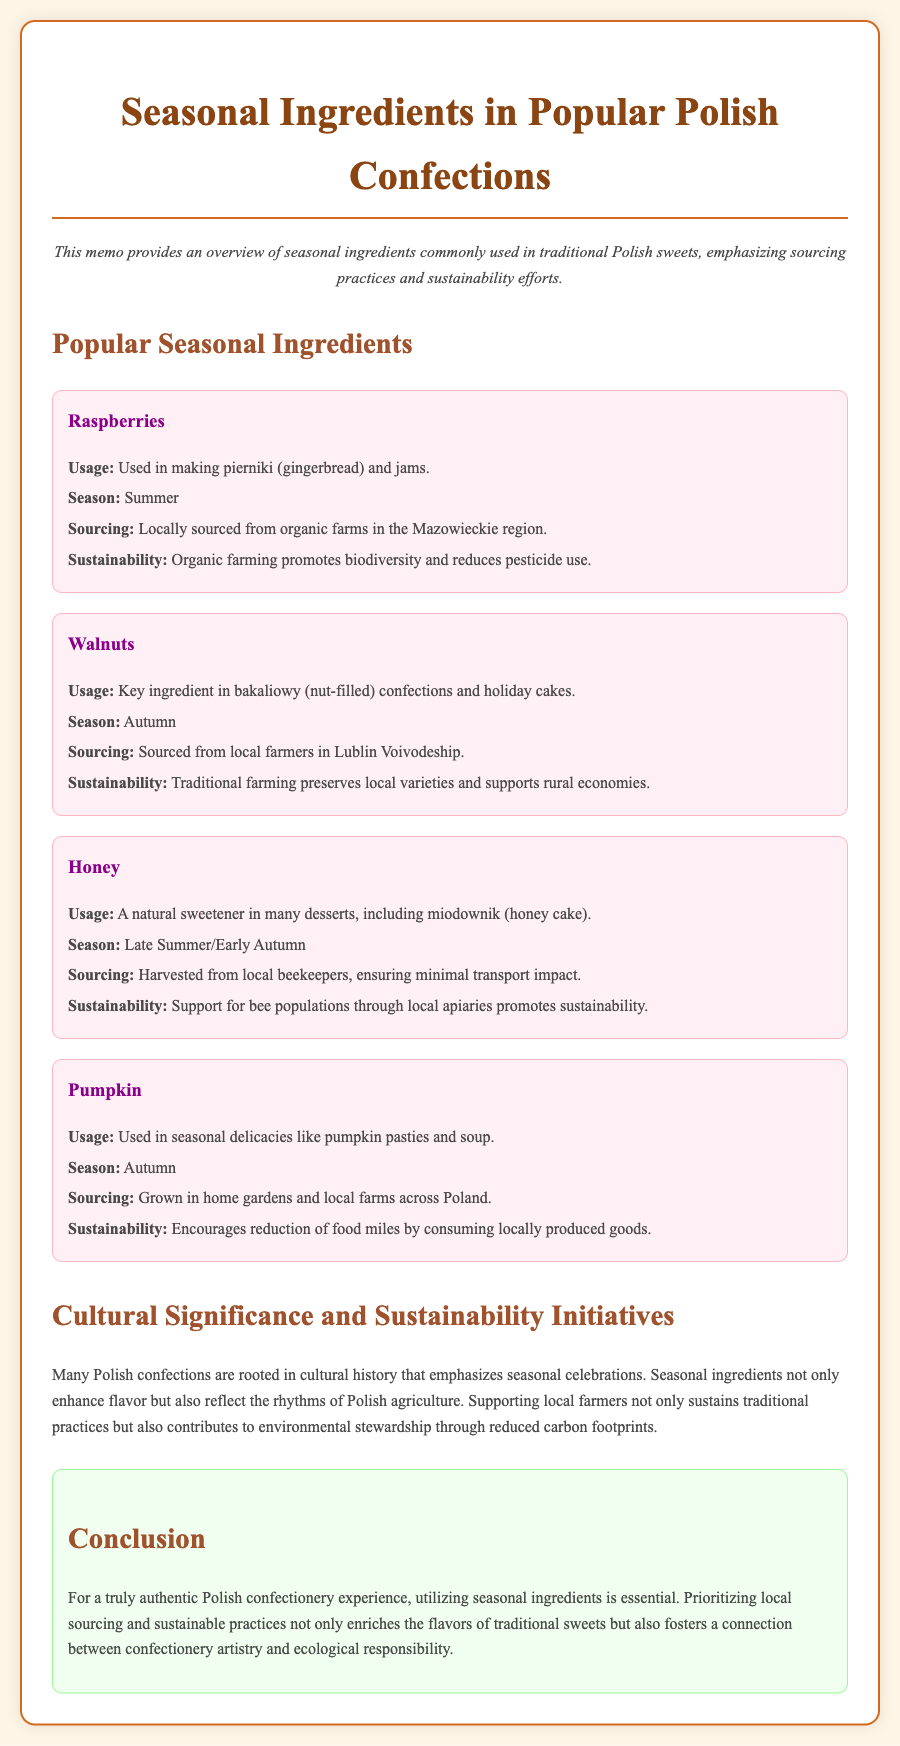What is the usage of raspberries? Raspberries are used in making pierniki and jams, as mentioned in the document.
Answer: pierniki and jams What season are walnuts harvested? The document states that walnuts are typically harvested in autumn.
Answer: Autumn Where are raspberries sourced from? The document specifies that raspberries are sourced from organic farms in the Mazowieckie region.
Answer: Mazowieckie region What is the sustainability benefit of sourcing honey locally? The document explains that sourcing honey locally supports bee populations through local apiaries, promoting sustainability.
Answer: Supports bee populations Which ingredient is used in miodownik? The document states that honey is used in miodownik (honey cake).
Answer: Honey What conclusion is drawn about seasonal ingredients? The document concludes that utilizing seasonal ingredients is essential for an authentic Polish confectionery experience.
Answer: Essential for authenticity What is the cultural significance of seasonal ingredients in Polish confections? The document notes that many Polish confections are rooted in cultural history that emphasizes seasonal celebrations.
Answer: Seasonal celebrations What kind of farms grow pumpkin? The document indicates that pumpkin is grown in home gardens and local farms across Poland.
Answer: Home gardens and local farms 